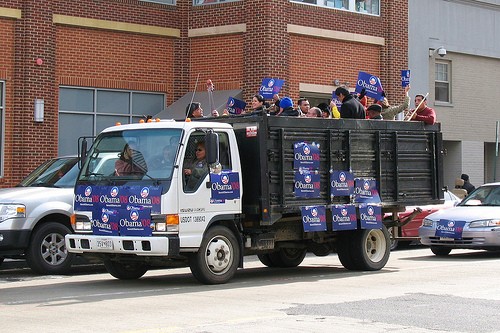Please provide a short description for this region: [0.39, 0.6, 0.8, 0.74]. The truck tires have two different types of white hubcaps. 